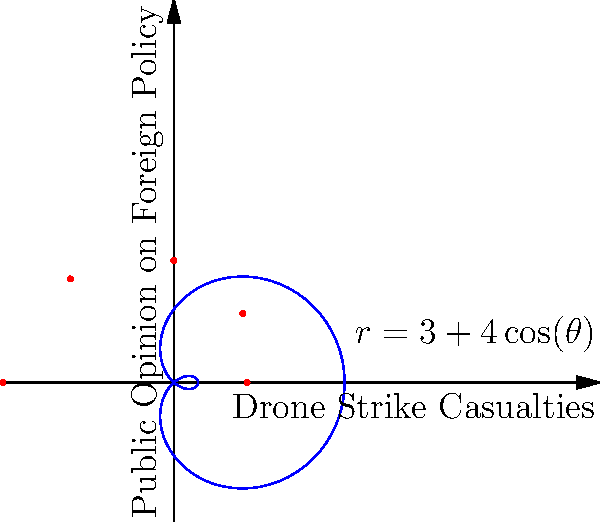Based on the polar graph representing the relationship between drone strike casualties and public opinion on foreign policy during Obama's administration, what can be inferred about the correlation between these two variables? How does this visualization inform our understanding of the impact of drone policy on public sentiment? To analyze this graph and its implications for Obama's drone policy, let's break it down step-by-step:

1. Graph interpretation:
   - The radial axis (r) represents drone strike casualties.
   - The angular axis (θ) represents public opinion on foreign policy.
   - The blue curve follows the equation $r = 3 + 4\cos(\theta)$.

2. Shape analysis:
   - The curve is cardioid-shaped, indicating a heart-like pattern.
   - This suggests a cyclical relationship between casualties and public opinion.

3. Correlation observation:
   - As θ increases from 0 to π, r decreases, then increases.
   - This implies that as public opinion shifts, casualties first decrease, then increase.

4. Policy implications:
   - The curve suggests that public opinion and casualty rates are inversely related for part of the cycle.
   - This could indicate that as public opinion becomes more negative, the administration might reduce drone strikes, leading to fewer casualties.

5. Cycle interpretation:
   - The full cycle (0 to 2π) might represent a complete term or policy phase.
   - The varying r values show that casualty rates fluctuate with changes in public opinion.

6. Obama's policy shifts:
   - The curve's shape suggests that Obama's administration may have adjusted drone policy in response to public sentiment.
   - The cyclical nature implies a dynamic relationship between policy decisions and public reaction.

7. Limitations:
   - This is a simplified model and doesn't account for all variables affecting drone policy and public opinion.
   - Real-world data might not fit this exact curve, but the general trend could be informative.

In conclusion, this visualization suggests a complex, cyclical relationship between drone strike casualties and public opinion on foreign policy during Obama's administration, indicating that policy decisions may have been influenced by public sentiment, and vice versa.
Answer: Cyclical inverse relationship between drone strike casualties and public opinion, suggesting policy adaptations in response to public sentiment. 